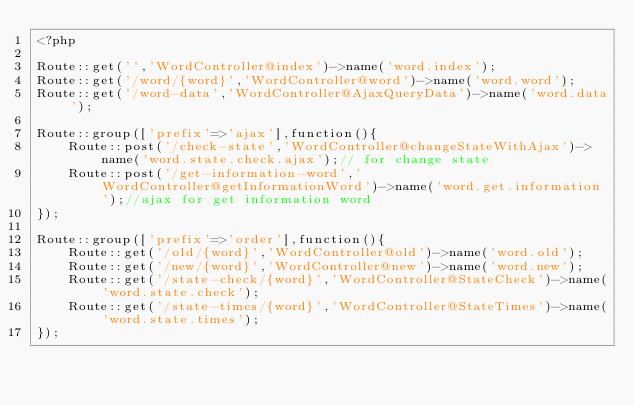<code> <loc_0><loc_0><loc_500><loc_500><_PHP_><?php

Route::get('','WordController@index')->name('word.index');
Route::get('/word/{word}','WordController@word')->name('word.word');
Route::get('/word-data','WordController@AjaxQueryData')->name('word.data');

Route::group(['prefix'=>'ajax'],function(){
    Route::post('/check-state','WordController@changeStateWithAjax')->name('word.state.check.ajax');// for change state
    Route::post('/get-information-word','WordController@getInformationWord')->name('word.get.information');//ajax for get information word
});

Route::group(['prefix'=>'order'],function(){
    Route::get('/old/{word}','WordController@old')->name('word.old');
    Route::get('/new/{word}','WordController@new')->name('word.new');
    Route::get('/state-check/{word}','WordController@StateCheck')->name('word.state.check');
    Route::get('/state-times/{word}','WordController@StateTimes')->name('word.state.times');
});
</code> 